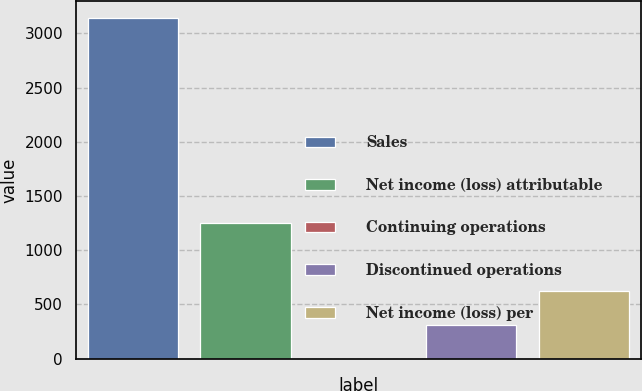Convert chart. <chart><loc_0><loc_0><loc_500><loc_500><bar_chart><fcel>Sales<fcel>Net income (loss) attributable<fcel>Continuing operations<fcel>Discontinued operations<fcel>Net income (loss) per<nl><fcel>3138<fcel>1255.27<fcel>0.11<fcel>313.9<fcel>627.69<nl></chart> 